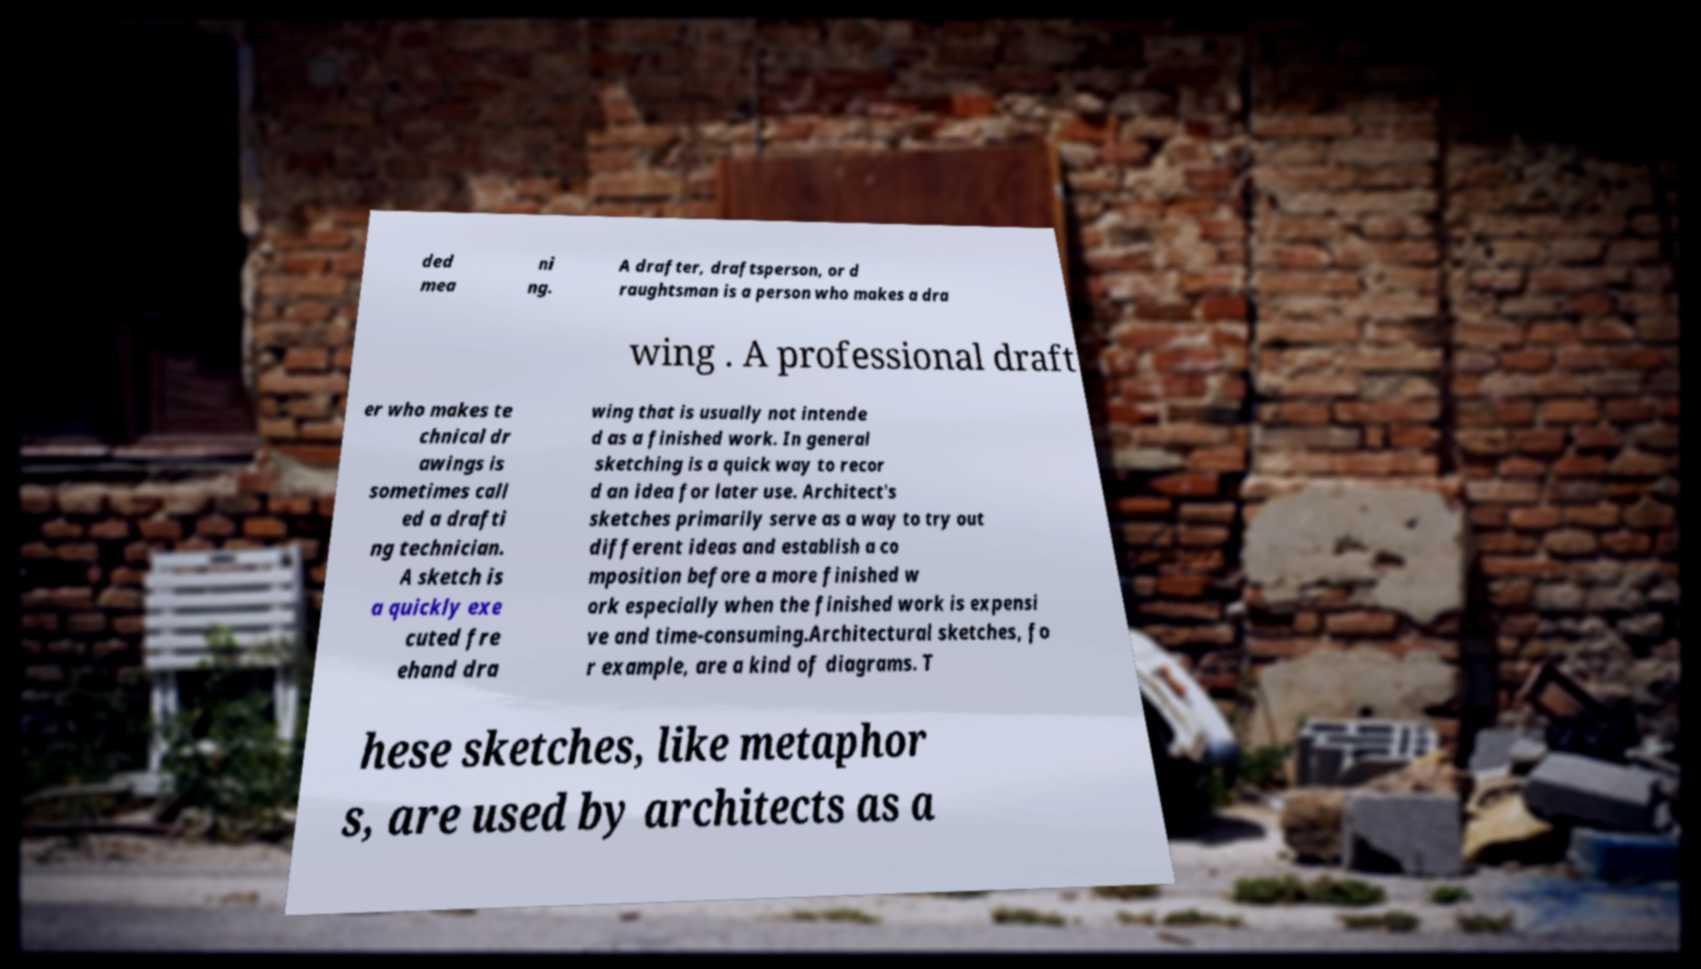Could you assist in decoding the text presented in this image and type it out clearly? ded mea ni ng. A drafter, draftsperson, or d raughtsman is a person who makes a dra wing . A professional draft er who makes te chnical dr awings is sometimes call ed a drafti ng technician. A sketch is a quickly exe cuted fre ehand dra wing that is usually not intende d as a finished work. In general sketching is a quick way to recor d an idea for later use. Architect's sketches primarily serve as a way to try out different ideas and establish a co mposition before a more finished w ork especially when the finished work is expensi ve and time-consuming.Architectural sketches, fo r example, are a kind of diagrams. T hese sketches, like metaphor s, are used by architects as a 